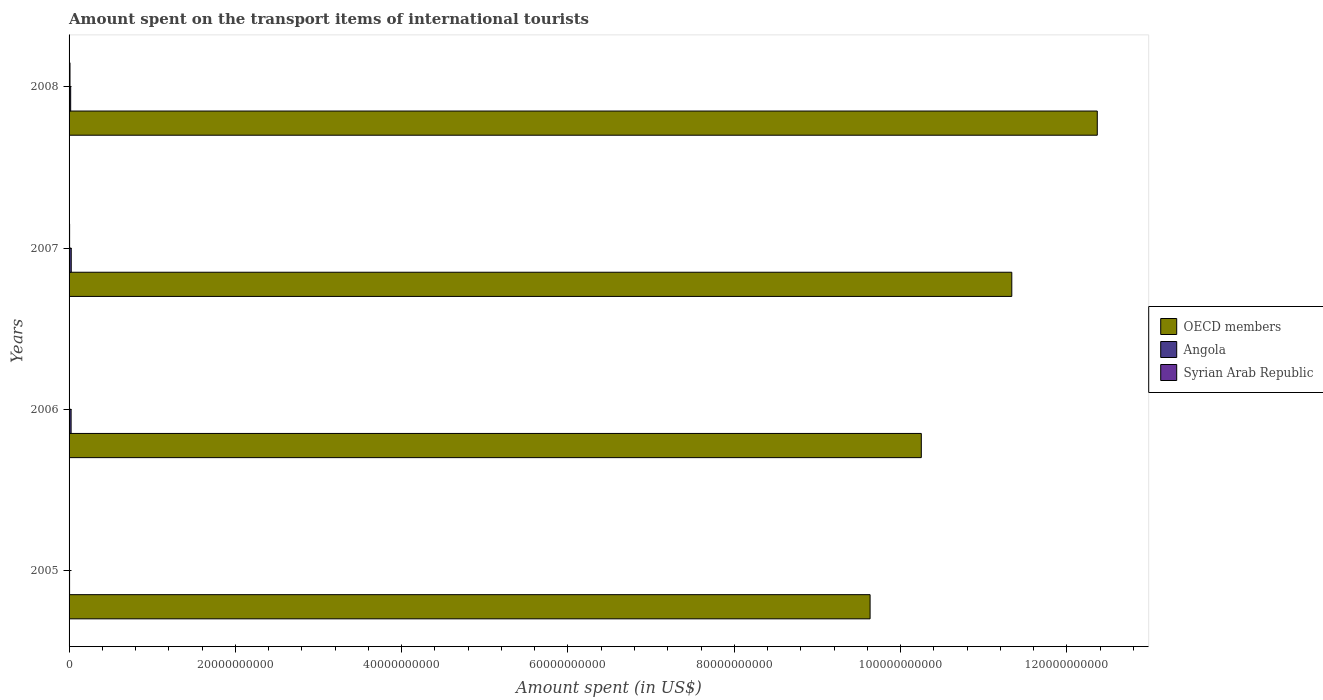How many different coloured bars are there?
Provide a succinct answer. 3. How many groups of bars are there?
Provide a succinct answer. 4. What is the amount spent on the transport items of international tourists in OECD members in 2008?
Keep it short and to the point. 1.24e+11. Across all years, what is the maximum amount spent on the transport items of international tourists in OECD members?
Your answer should be very brief. 1.24e+11. Across all years, what is the minimum amount spent on the transport items of international tourists in OECD members?
Offer a very short reply. 9.63e+1. In which year was the amount spent on the transport items of international tourists in Angola maximum?
Give a very brief answer. 2007. In which year was the amount spent on the transport items of international tourists in OECD members minimum?
Provide a succinct answer. 2005. What is the total amount spent on the transport items of international tourists in Syrian Arab Republic in the graph?
Your response must be concise. 2.56e+08. What is the difference between the amount spent on the transport items of international tourists in OECD members in 2006 and that in 2007?
Keep it short and to the point. -1.09e+1. What is the difference between the amount spent on the transport items of international tourists in OECD members in 2005 and the amount spent on the transport items of international tourists in Angola in 2008?
Make the answer very short. 9.61e+1. What is the average amount spent on the transport items of international tourists in Syrian Arab Republic per year?
Keep it short and to the point. 6.40e+07. In the year 2007, what is the difference between the amount spent on the transport items of international tourists in OECD members and amount spent on the transport items of international tourists in Angola?
Provide a short and direct response. 1.13e+11. What is the ratio of the amount spent on the transport items of international tourists in Angola in 2005 to that in 2007?
Your answer should be compact. 0.23. Is the amount spent on the transport items of international tourists in Angola in 2005 less than that in 2006?
Provide a short and direct response. Yes. Is the difference between the amount spent on the transport items of international tourists in OECD members in 2005 and 2008 greater than the difference between the amount spent on the transport items of international tourists in Angola in 2005 and 2008?
Offer a very short reply. No. What is the difference between the highest and the second highest amount spent on the transport items of international tourists in Angola?
Ensure brevity in your answer.  1.60e+07. What is the difference between the highest and the lowest amount spent on the transport items of international tourists in OECD members?
Offer a terse response. 2.73e+1. In how many years, is the amount spent on the transport items of international tourists in Syrian Arab Republic greater than the average amount spent on the transport items of international tourists in Syrian Arab Republic taken over all years?
Make the answer very short. 2. Is the sum of the amount spent on the transport items of international tourists in OECD members in 2006 and 2008 greater than the maximum amount spent on the transport items of international tourists in Syrian Arab Republic across all years?
Keep it short and to the point. Yes. What does the 3rd bar from the bottom in 2006 represents?
Offer a terse response. Syrian Arab Republic. How many years are there in the graph?
Give a very brief answer. 4. What is the difference between two consecutive major ticks on the X-axis?
Offer a very short reply. 2.00e+1. Does the graph contain any zero values?
Give a very brief answer. No. How are the legend labels stacked?
Provide a succinct answer. Vertical. What is the title of the graph?
Keep it short and to the point. Amount spent on the transport items of international tourists. What is the label or title of the X-axis?
Your answer should be compact. Amount spent (in US$). What is the Amount spent (in US$) in OECD members in 2005?
Provide a succinct answer. 9.63e+1. What is the Amount spent (in US$) of Angola in 2005?
Your answer should be very brief. 6.10e+07. What is the Amount spent (in US$) of Syrian Arab Republic in 2005?
Your answer should be very brief. 3.40e+07. What is the Amount spent (in US$) in OECD members in 2006?
Ensure brevity in your answer.  1.02e+11. What is the Amount spent (in US$) of Angola in 2006?
Make the answer very short. 2.45e+08. What is the Amount spent (in US$) of Syrian Arab Republic in 2006?
Provide a succinct answer. 4.50e+07. What is the Amount spent (in US$) in OECD members in 2007?
Ensure brevity in your answer.  1.13e+11. What is the Amount spent (in US$) in Angola in 2007?
Give a very brief answer. 2.61e+08. What is the Amount spent (in US$) in Syrian Arab Republic in 2007?
Give a very brief answer. 6.50e+07. What is the Amount spent (in US$) of OECD members in 2008?
Offer a very short reply. 1.24e+11. What is the Amount spent (in US$) in Angola in 2008?
Your response must be concise. 1.93e+08. What is the Amount spent (in US$) in Syrian Arab Republic in 2008?
Keep it short and to the point. 1.12e+08. Across all years, what is the maximum Amount spent (in US$) in OECD members?
Offer a very short reply. 1.24e+11. Across all years, what is the maximum Amount spent (in US$) of Angola?
Make the answer very short. 2.61e+08. Across all years, what is the maximum Amount spent (in US$) in Syrian Arab Republic?
Your answer should be very brief. 1.12e+08. Across all years, what is the minimum Amount spent (in US$) in OECD members?
Make the answer very short. 9.63e+1. Across all years, what is the minimum Amount spent (in US$) of Angola?
Your response must be concise. 6.10e+07. Across all years, what is the minimum Amount spent (in US$) in Syrian Arab Republic?
Offer a very short reply. 3.40e+07. What is the total Amount spent (in US$) of OECD members in the graph?
Provide a succinct answer. 4.36e+11. What is the total Amount spent (in US$) in Angola in the graph?
Keep it short and to the point. 7.60e+08. What is the total Amount spent (in US$) of Syrian Arab Republic in the graph?
Make the answer very short. 2.56e+08. What is the difference between the Amount spent (in US$) in OECD members in 2005 and that in 2006?
Keep it short and to the point. -6.16e+09. What is the difference between the Amount spent (in US$) of Angola in 2005 and that in 2006?
Keep it short and to the point. -1.84e+08. What is the difference between the Amount spent (in US$) of Syrian Arab Republic in 2005 and that in 2006?
Your response must be concise. -1.10e+07. What is the difference between the Amount spent (in US$) in OECD members in 2005 and that in 2007?
Offer a very short reply. -1.70e+1. What is the difference between the Amount spent (in US$) in Angola in 2005 and that in 2007?
Your answer should be compact. -2.00e+08. What is the difference between the Amount spent (in US$) in Syrian Arab Republic in 2005 and that in 2007?
Give a very brief answer. -3.10e+07. What is the difference between the Amount spent (in US$) in OECD members in 2005 and that in 2008?
Give a very brief answer. -2.73e+1. What is the difference between the Amount spent (in US$) of Angola in 2005 and that in 2008?
Give a very brief answer. -1.32e+08. What is the difference between the Amount spent (in US$) in Syrian Arab Republic in 2005 and that in 2008?
Your answer should be compact. -7.80e+07. What is the difference between the Amount spent (in US$) in OECD members in 2006 and that in 2007?
Keep it short and to the point. -1.09e+1. What is the difference between the Amount spent (in US$) of Angola in 2006 and that in 2007?
Provide a short and direct response. -1.60e+07. What is the difference between the Amount spent (in US$) of Syrian Arab Republic in 2006 and that in 2007?
Keep it short and to the point. -2.00e+07. What is the difference between the Amount spent (in US$) in OECD members in 2006 and that in 2008?
Make the answer very short. -2.12e+1. What is the difference between the Amount spent (in US$) of Angola in 2006 and that in 2008?
Keep it short and to the point. 5.20e+07. What is the difference between the Amount spent (in US$) in Syrian Arab Republic in 2006 and that in 2008?
Give a very brief answer. -6.70e+07. What is the difference between the Amount spent (in US$) of OECD members in 2007 and that in 2008?
Provide a succinct answer. -1.03e+1. What is the difference between the Amount spent (in US$) in Angola in 2007 and that in 2008?
Your answer should be compact. 6.80e+07. What is the difference between the Amount spent (in US$) in Syrian Arab Republic in 2007 and that in 2008?
Your answer should be compact. -4.70e+07. What is the difference between the Amount spent (in US$) of OECD members in 2005 and the Amount spent (in US$) of Angola in 2006?
Provide a succinct answer. 9.61e+1. What is the difference between the Amount spent (in US$) in OECD members in 2005 and the Amount spent (in US$) in Syrian Arab Republic in 2006?
Your answer should be very brief. 9.63e+1. What is the difference between the Amount spent (in US$) in Angola in 2005 and the Amount spent (in US$) in Syrian Arab Republic in 2006?
Offer a very short reply. 1.60e+07. What is the difference between the Amount spent (in US$) of OECD members in 2005 and the Amount spent (in US$) of Angola in 2007?
Ensure brevity in your answer.  9.61e+1. What is the difference between the Amount spent (in US$) of OECD members in 2005 and the Amount spent (in US$) of Syrian Arab Republic in 2007?
Make the answer very short. 9.63e+1. What is the difference between the Amount spent (in US$) in Angola in 2005 and the Amount spent (in US$) in Syrian Arab Republic in 2007?
Offer a terse response. -4.00e+06. What is the difference between the Amount spent (in US$) of OECD members in 2005 and the Amount spent (in US$) of Angola in 2008?
Make the answer very short. 9.61e+1. What is the difference between the Amount spent (in US$) in OECD members in 2005 and the Amount spent (in US$) in Syrian Arab Republic in 2008?
Make the answer very short. 9.62e+1. What is the difference between the Amount spent (in US$) of Angola in 2005 and the Amount spent (in US$) of Syrian Arab Republic in 2008?
Offer a terse response. -5.10e+07. What is the difference between the Amount spent (in US$) in OECD members in 2006 and the Amount spent (in US$) in Angola in 2007?
Your answer should be very brief. 1.02e+11. What is the difference between the Amount spent (in US$) in OECD members in 2006 and the Amount spent (in US$) in Syrian Arab Republic in 2007?
Your answer should be compact. 1.02e+11. What is the difference between the Amount spent (in US$) in Angola in 2006 and the Amount spent (in US$) in Syrian Arab Republic in 2007?
Your response must be concise. 1.80e+08. What is the difference between the Amount spent (in US$) in OECD members in 2006 and the Amount spent (in US$) in Angola in 2008?
Give a very brief answer. 1.02e+11. What is the difference between the Amount spent (in US$) in OECD members in 2006 and the Amount spent (in US$) in Syrian Arab Republic in 2008?
Offer a very short reply. 1.02e+11. What is the difference between the Amount spent (in US$) of Angola in 2006 and the Amount spent (in US$) of Syrian Arab Republic in 2008?
Ensure brevity in your answer.  1.33e+08. What is the difference between the Amount spent (in US$) of OECD members in 2007 and the Amount spent (in US$) of Angola in 2008?
Provide a short and direct response. 1.13e+11. What is the difference between the Amount spent (in US$) in OECD members in 2007 and the Amount spent (in US$) in Syrian Arab Republic in 2008?
Offer a very short reply. 1.13e+11. What is the difference between the Amount spent (in US$) of Angola in 2007 and the Amount spent (in US$) of Syrian Arab Republic in 2008?
Offer a terse response. 1.49e+08. What is the average Amount spent (in US$) of OECD members per year?
Offer a very short reply. 1.09e+11. What is the average Amount spent (in US$) of Angola per year?
Provide a short and direct response. 1.90e+08. What is the average Amount spent (in US$) in Syrian Arab Republic per year?
Offer a terse response. 6.40e+07. In the year 2005, what is the difference between the Amount spent (in US$) of OECD members and Amount spent (in US$) of Angola?
Your response must be concise. 9.63e+1. In the year 2005, what is the difference between the Amount spent (in US$) in OECD members and Amount spent (in US$) in Syrian Arab Republic?
Provide a short and direct response. 9.63e+1. In the year 2005, what is the difference between the Amount spent (in US$) of Angola and Amount spent (in US$) of Syrian Arab Republic?
Your answer should be compact. 2.70e+07. In the year 2006, what is the difference between the Amount spent (in US$) of OECD members and Amount spent (in US$) of Angola?
Provide a succinct answer. 1.02e+11. In the year 2006, what is the difference between the Amount spent (in US$) of OECD members and Amount spent (in US$) of Syrian Arab Republic?
Your answer should be very brief. 1.02e+11. In the year 2007, what is the difference between the Amount spent (in US$) of OECD members and Amount spent (in US$) of Angola?
Make the answer very short. 1.13e+11. In the year 2007, what is the difference between the Amount spent (in US$) of OECD members and Amount spent (in US$) of Syrian Arab Republic?
Provide a succinct answer. 1.13e+11. In the year 2007, what is the difference between the Amount spent (in US$) of Angola and Amount spent (in US$) of Syrian Arab Republic?
Ensure brevity in your answer.  1.96e+08. In the year 2008, what is the difference between the Amount spent (in US$) in OECD members and Amount spent (in US$) in Angola?
Offer a terse response. 1.23e+11. In the year 2008, what is the difference between the Amount spent (in US$) of OECD members and Amount spent (in US$) of Syrian Arab Republic?
Offer a very short reply. 1.24e+11. In the year 2008, what is the difference between the Amount spent (in US$) of Angola and Amount spent (in US$) of Syrian Arab Republic?
Your response must be concise. 8.10e+07. What is the ratio of the Amount spent (in US$) of OECD members in 2005 to that in 2006?
Your response must be concise. 0.94. What is the ratio of the Amount spent (in US$) of Angola in 2005 to that in 2006?
Ensure brevity in your answer.  0.25. What is the ratio of the Amount spent (in US$) in Syrian Arab Republic in 2005 to that in 2006?
Your answer should be compact. 0.76. What is the ratio of the Amount spent (in US$) of OECD members in 2005 to that in 2007?
Your response must be concise. 0.85. What is the ratio of the Amount spent (in US$) of Angola in 2005 to that in 2007?
Offer a very short reply. 0.23. What is the ratio of the Amount spent (in US$) of Syrian Arab Republic in 2005 to that in 2007?
Your response must be concise. 0.52. What is the ratio of the Amount spent (in US$) in OECD members in 2005 to that in 2008?
Keep it short and to the point. 0.78. What is the ratio of the Amount spent (in US$) of Angola in 2005 to that in 2008?
Your response must be concise. 0.32. What is the ratio of the Amount spent (in US$) of Syrian Arab Republic in 2005 to that in 2008?
Keep it short and to the point. 0.3. What is the ratio of the Amount spent (in US$) in OECD members in 2006 to that in 2007?
Make the answer very short. 0.9. What is the ratio of the Amount spent (in US$) in Angola in 2006 to that in 2007?
Offer a very short reply. 0.94. What is the ratio of the Amount spent (in US$) in Syrian Arab Republic in 2006 to that in 2007?
Provide a short and direct response. 0.69. What is the ratio of the Amount spent (in US$) in OECD members in 2006 to that in 2008?
Ensure brevity in your answer.  0.83. What is the ratio of the Amount spent (in US$) of Angola in 2006 to that in 2008?
Provide a succinct answer. 1.27. What is the ratio of the Amount spent (in US$) in Syrian Arab Republic in 2006 to that in 2008?
Provide a succinct answer. 0.4. What is the ratio of the Amount spent (in US$) of OECD members in 2007 to that in 2008?
Provide a succinct answer. 0.92. What is the ratio of the Amount spent (in US$) in Angola in 2007 to that in 2008?
Your response must be concise. 1.35. What is the ratio of the Amount spent (in US$) of Syrian Arab Republic in 2007 to that in 2008?
Make the answer very short. 0.58. What is the difference between the highest and the second highest Amount spent (in US$) of OECD members?
Keep it short and to the point. 1.03e+1. What is the difference between the highest and the second highest Amount spent (in US$) of Angola?
Offer a very short reply. 1.60e+07. What is the difference between the highest and the second highest Amount spent (in US$) of Syrian Arab Republic?
Keep it short and to the point. 4.70e+07. What is the difference between the highest and the lowest Amount spent (in US$) of OECD members?
Your answer should be very brief. 2.73e+1. What is the difference between the highest and the lowest Amount spent (in US$) of Syrian Arab Republic?
Your answer should be compact. 7.80e+07. 